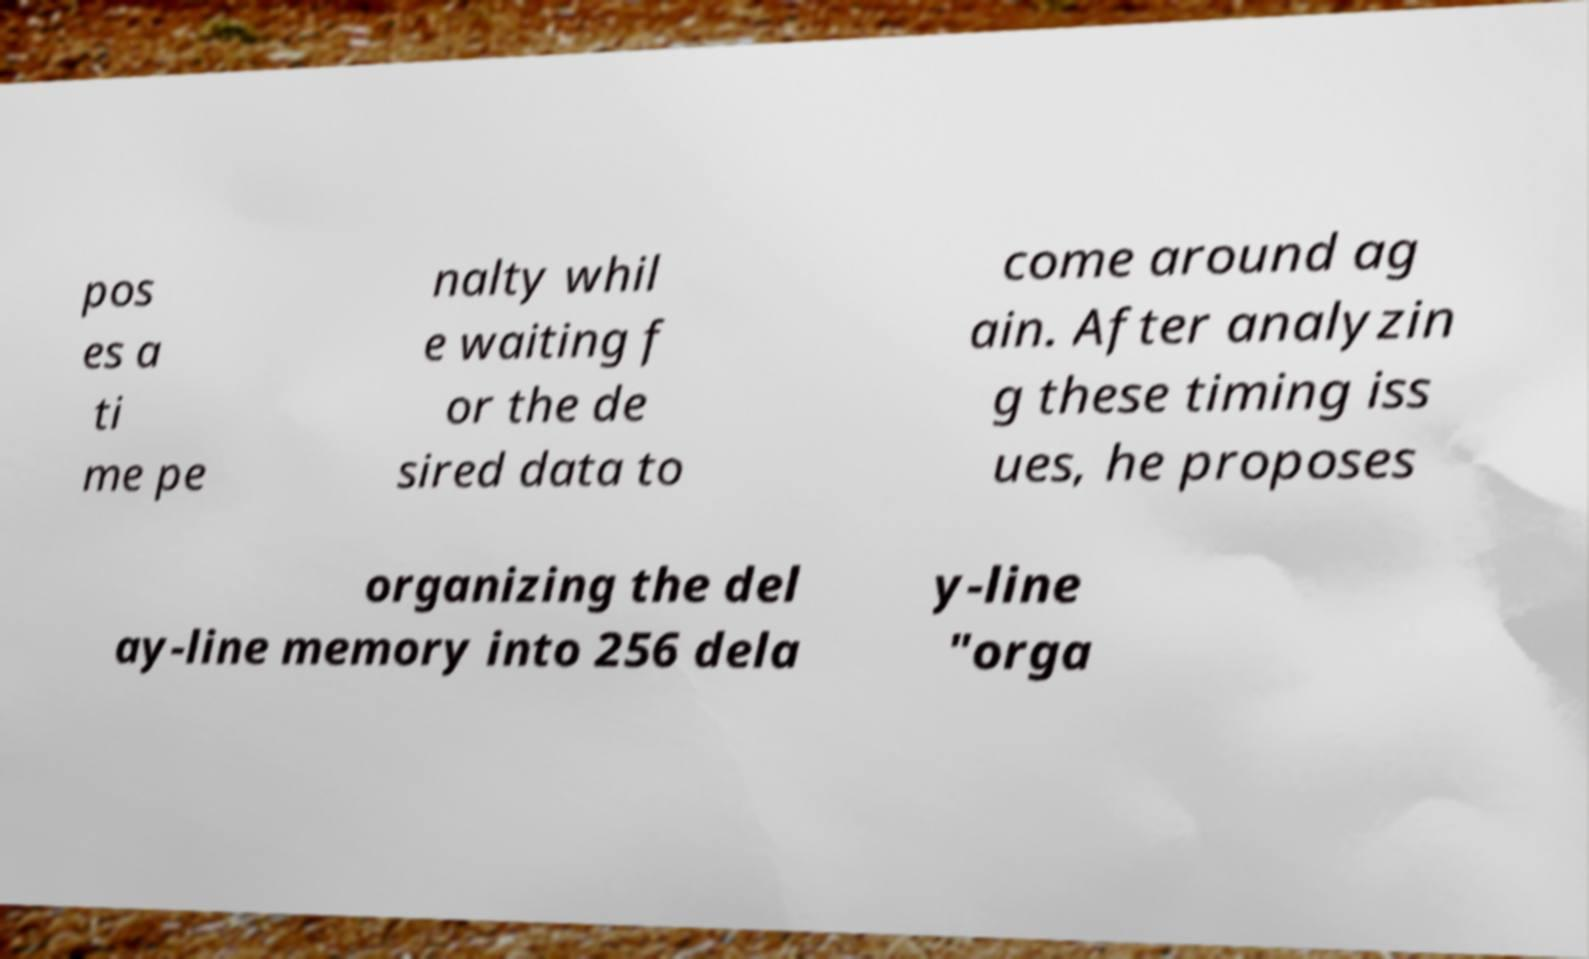Please read and relay the text visible in this image. What does it say? pos es a ti me pe nalty whil e waiting f or the de sired data to come around ag ain. After analyzin g these timing iss ues, he proposes organizing the del ay-line memory into 256 dela y-line "orga 